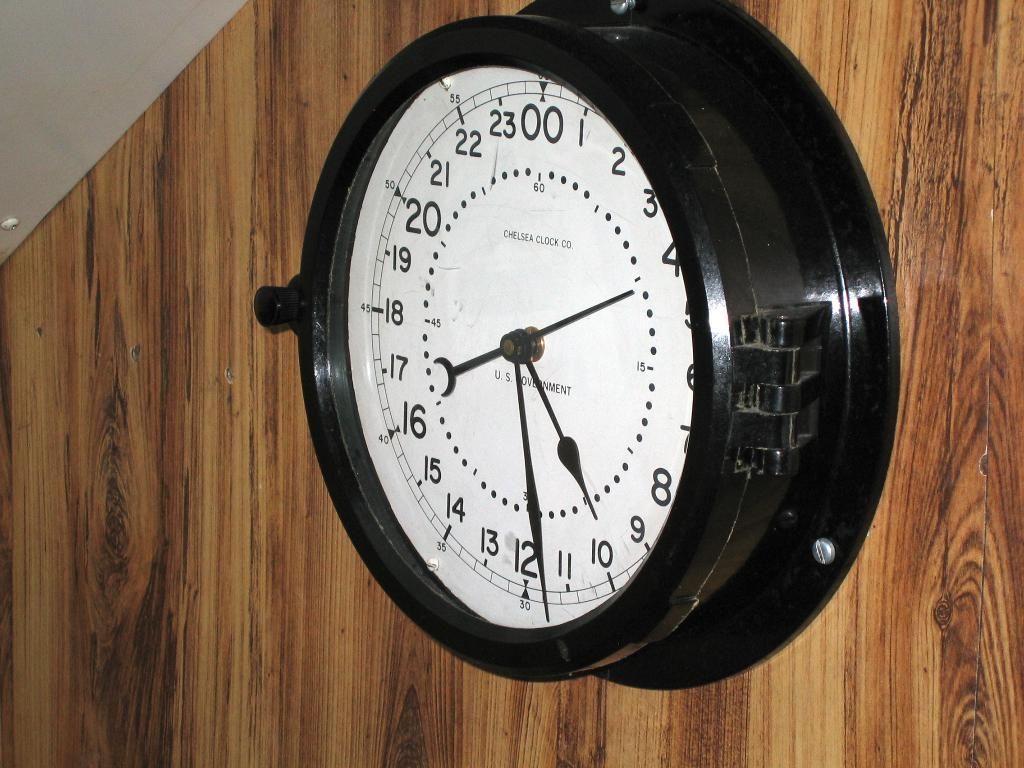<image>
Offer a succinct explanation of the picture presented. White clock on a wooden wall that has the hands on the numbers 10 and 12. 